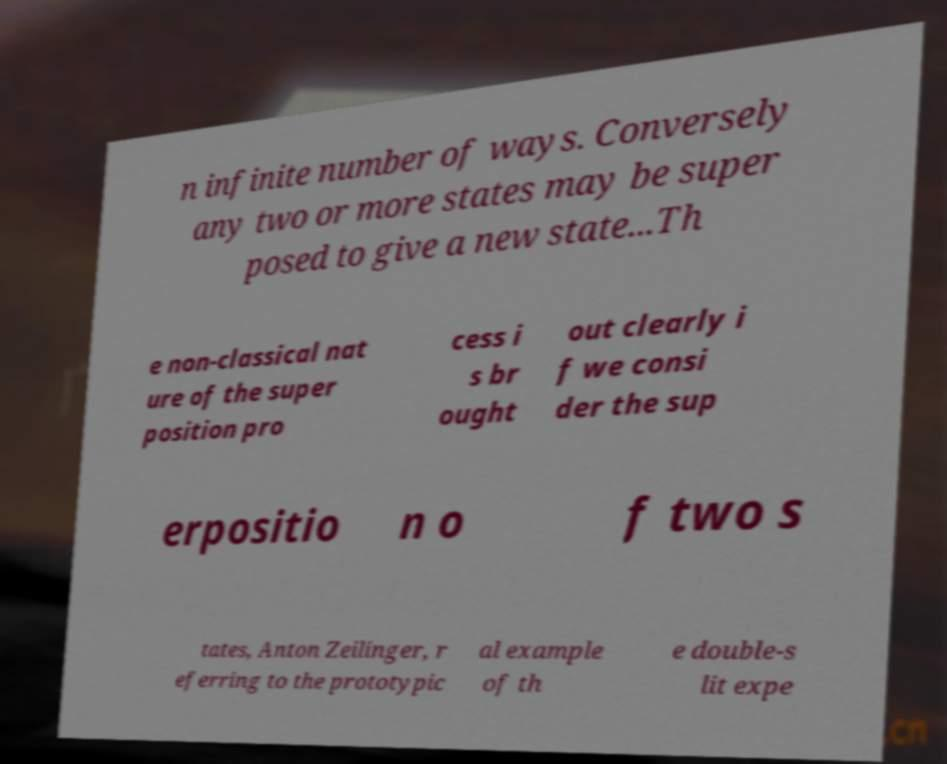Can you accurately transcribe the text from the provided image for me? n infinite number of ways. Conversely any two or more states may be super posed to give a new state...Th e non-classical nat ure of the super position pro cess i s br ought out clearly i f we consi der the sup erpositio n o f two s tates, Anton Zeilinger, r eferring to the prototypic al example of th e double-s lit expe 